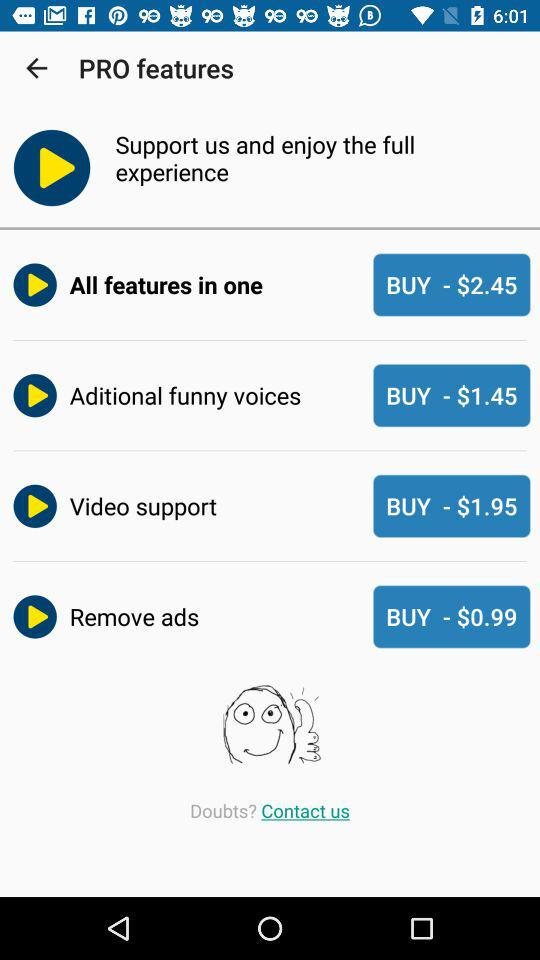Which feature has a price of $0.99? The feature that has a price of $0.99 is "Remove ads". 